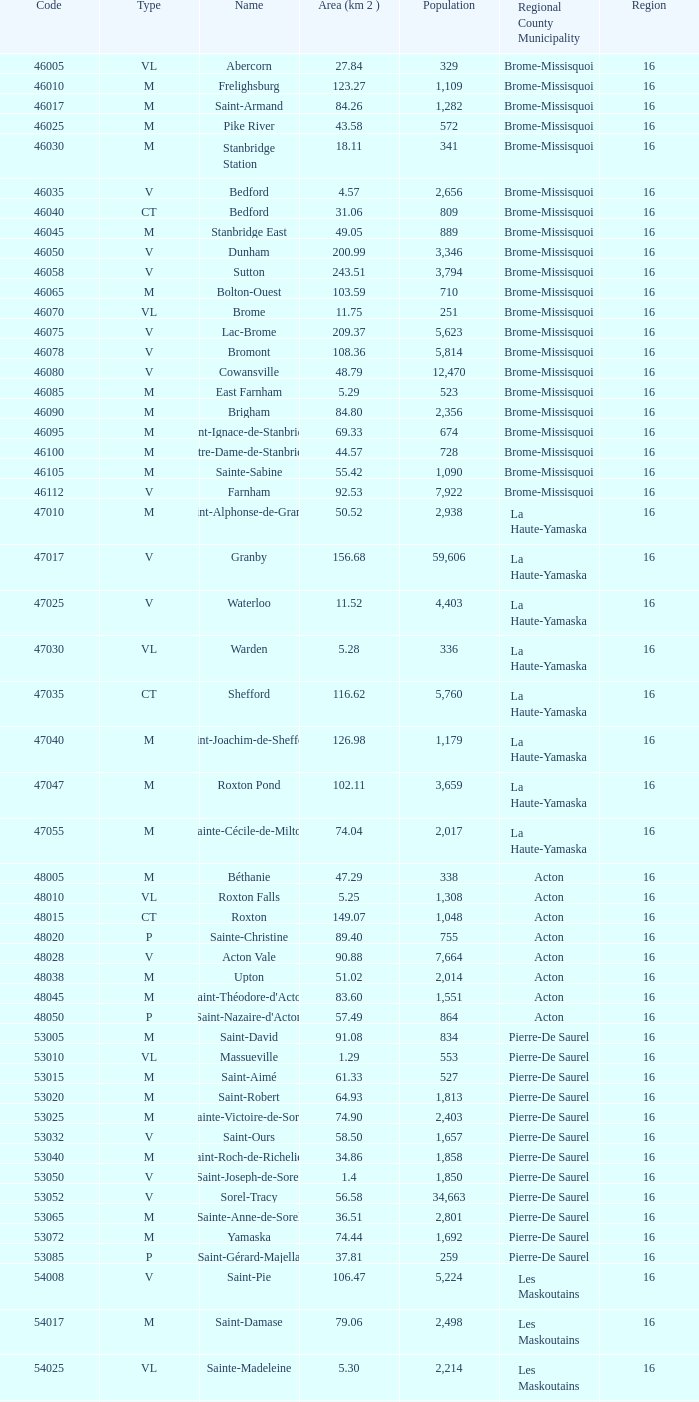Write the full table. {'header': ['Code', 'Type', 'Name', 'Area (km 2 )', 'Population', 'Regional County Municipality', 'Region'], 'rows': [['46005', 'VL', 'Abercorn', '27.84', '329', 'Brome-Missisquoi', '16'], ['46010', 'M', 'Frelighsburg', '123.27', '1,109', 'Brome-Missisquoi', '16'], ['46017', 'M', 'Saint-Armand', '84.26', '1,282', 'Brome-Missisquoi', '16'], ['46025', 'M', 'Pike River', '43.58', '572', 'Brome-Missisquoi', '16'], ['46030', 'M', 'Stanbridge Station', '18.11', '341', 'Brome-Missisquoi', '16'], ['46035', 'V', 'Bedford', '4.57', '2,656', 'Brome-Missisquoi', '16'], ['46040', 'CT', 'Bedford', '31.06', '809', 'Brome-Missisquoi', '16'], ['46045', 'M', 'Stanbridge East', '49.05', '889', 'Brome-Missisquoi', '16'], ['46050', 'V', 'Dunham', '200.99', '3,346', 'Brome-Missisquoi', '16'], ['46058', 'V', 'Sutton', '243.51', '3,794', 'Brome-Missisquoi', '16'], ['46065', 'M', 'Bolton-Ouest', '103.59', '710', 'Brome-Missisquoi', '16'], ['46070', 'VL', 'Brome', '11.75', '251', 'Brome-Missisquoi', '16'], ['46075', 'V', 'Lac-Brome', '209.37', '5,623', 'Brome-Missisquoi', '16'], ['46078', 'V', 'Bromont', '108.36', '5,814', 'Brome-Missisquoi', '16'], ['46080', 'V', 'Cowansville', '48.79', '12,470', 'Brome-Missisquoi', '16'], ['46085', 'M', 'East Farnham', '5.29', '523', 'Brome-Missisquoi', '16'], ['46090', 'M', 'Brigham', '84.80', '2,356', 'Brome-Missisquoi', '16'], ['46095', 'M', 'Saint-Ignace-de-Stanbridge', '69.33', '674', 'Brome-Missisquoi', '16'], ['46100', 'M', 'Notre-Dame-de-Stanbridge', '44.57', '728', 'Brome-Missisquoi', '16'], ['46105', 'M', 'Sainte-Sabine', '55.42', '1,090', 'Brome-Missisquoi', '16'], ['46112', 'V', 'Farnham', '92.53', '7,922', 'Brome-Missisquoi', '16'], ['47010', 'M', 'Saint-Alphonse-de-Granby', '50.52', '2,938', 'La Haute-Yamaska', '16'], ['47017', 'V', 'Granby', '156.68', '59,606', 'La Haute-Yamaska', '16'], ['47025', 'V', 'Waterloo', '11.52', '4,403', 'La Haute-Yamaska', '16'], ['47030', 'VL', 'Warden', '5.28', '336', 'La Haute-Yamaska', '16'], ['47035', 'CT', 'Shefford', '116.62', '5,760', 'La Haute-Yamaska', '16'], ['47040', 'M', 'Saint-Joachim-de-Shefford', '126.98', '1,179', 'La Haute-Yamaska', '16'], ['47047', 'M', 'Roxton Pond', '102.11', '3,659', 'La Haute-Yamaska', '16'], ['47055', 'M', 'Sainte-Cécile-de-Milton', '74.04', '2,017', 'La Haute-Yamaska', '16'], ['48005', 'M', 'Béthanie', '47.29', '338', 'Acton', '16'], ['48010', 'VL', 'Roxton Falls', '5.25', '1,308', 'Acton', '16'], ['48015', 'CT', 'Roxton', '149.07', '1,048', 'Acton', '16'], ['48020', 'P', 'Sainte-Christine', '89.40', '755', 'Acton', '16'], ['48028', 'V', 'Acton Vale', '90.88', '7,664', 'Acton', '16'], ['48038', 'M', 'Upton', '51.02', '2,014', 'Acton', '16'], ['48045', 'M', "Saint-Théodore-d'Acton", '83.60', '1,551', 'Acton', '16'], ['48050', 'P', "Saint-Nazaire-d'Acton", '57.49', '864', 'Acton', '16'], ['53005', 'M', 'Saint-David', '91.08', '834', 'Pierre-De Saurel', '16'], ['53010', 'VL', 'Massueville', '1.29', '553', 'Pierre-De Saurel', '16'], ['53015', 'M', 'Saint-Aimé', '61.33', '527', 'Pierre-De Saurel', '16'], ['53020', 'M', 'Saint-Robert', '64.93', '1,813', 'Pierre-De Saurel', '16'], ['53025', 'M', 'Sainte-Victoire-de-Sorel', '74.90', '2,403', 'Pierre-De Saurel', '16'], ['53032', 'V', 'Saint-Ours', '58.50', '1,657', 'Pierre-De Saurel', '16'], ['53040', 'M', 'Saint-Roch-de-Richelieu', '34.86', '1,858', 'Pierre-De Saurel', '16'], ['53050', 'V', 'Saint-Joseph-de-Sorel', '1.4', '1,850', 'Pierre-De Saurel', '16'], ['53052', 'V', 'Sorel-Tracy', '56.58', '34,663', 'Pierre-De Saurel', '16'], ['53065', 'M', 'Sainte-Anne-de-Sorel', '36.51', '2,801', 'Pierre-De Saurel', '16'], ['53072', 'M', 'Yamaska', '74.44', '1,692', 'Pierre-De Saurel', '16'], ['53085', 'P', 'Saint-Gérard-Majella', '37.81', '259', 'Pierre-De Saurel', '16'], ['54008', 'V', 'Saint-Pie', '106.47', '5,224', 'Les Maskoutains', '16'], ['54017', 'M', 'Saint-Damase', '79.06', '2,498', 'Les Maskoutains', '16'], ['54025', 'VL', 'Sainte-Madeleine', '5.30', '2,214', 'Les Maskoutains', '16'], ['54030', 'P', 'Sainte-Marie-Madeleine', '49.53', '2,713', 'Les Maskoutains', '16'], ['54035', 'M', 'La Présentation', '104.71', '2,078', 'Les Maskoutains', '16'], ['54048', 'V', 'Saint-Hyacinthe', '189.11', '51,984', 'Les Maskoutains', '16'], ['54060', 'M', 'Saint-Dominique', '70.16', '2,308', 'Les Maskoutains', '16'], ['54065', 'M', 'Saint-Valérien-de-Milton', '106.44', '1,785', 'Les Maskoutains', '16'], ['54072', 'M', 'Saint-Liboire', '72.90', '2,846', 'Les Maskoutains', '16'], ['54090', 'M', 'Saint-Simon', '68.66', '1,136', 'Les Maskoutains', '16'], ['54095', 'M', 'Sainte-Hélène-de-Bagot', '73.53', '1,541', 'Les Maskoutains', '16'], ['54100', 'M', 'Saint-Hugues', '89.30', '1,420', 'Les Maskoutains', '16'], ['54105', 'M', 'Saint-Barnabé-Sud', '57.08', '881', 'Les Maskoutains', '16'], ['54110', 'M', 'Saint-Jude', '77.36', '1,111', 'Les Maskoutains', '16'], ['54115', 'M', 'Saint-Bernard-de-Michaudville', '64.80', '581', 'Les Maskoutains', '16'], ['54120', 'M', 'Saint-Louis', '45.92', '752', 'Les Maskoutains', '16'], ['54125', 'M', 'Saint-Marcel-de-Richelieu', '50.21', '613', 'Les Maskoutains', '16'], ['55008', 'M', 'Ange-Gardien', '89.07', '1,994', 'Rouville', '16'], ['55015', 'M', "Saint-Paul-d'Abbotsford", '79.59', '2,910', 'Rouville', '16'], ['55023', 'V', 'Saint-Césaire', '84.14', '5,039', 'Rouville', '16'], ['55030', 'M', 'Sainte-Angèle-de-Monnoir', '45.49', '1,474', 'Rouville', '16'], ['55037', 'M', 'Rougemont', '44.48', '2,631', 'Rouville', '16'], ['55048', 'V', 'Marieville', '64.25', '7,377', 'Rouville', '16'], ['55057', 'V', 'Richelieu', '29.75', '5,658', 'Rouville', '16'], ['55065', 'M', 'Saint-Mathias-sur-Richelieu', '48.22', '4,453', 'Rouville', '16'], ['56005', 'M', 'Venise-en-Québec', '13.57', '1,414', 'Le Haut-Richelieu', '16'], ['56010', 'M', 'Saint-Georges-de-Clarenceville', '63.76', '1,170', 'Le Haut-Richelieu', '16'], ['56015', 'M', 'Noyan', '43.79', '1,192', 'Le Haut-Richelieu', '16'], ['56023', 'M', 'Lacolle', '49.17', '2,502', 'Le Haut-Richelieu', '16'], ['56030', 'M', 'Saint-Valentin', '40.09', '527', 'Le Haut-Richelieu', '16'], ['56035', 'M', "Saint-Paul-de-l'Île-aux-Noix", '29.47', '2,049', 'Le Haut-Richelieu', '16'], ['56042', 'M', 'Henryville', '64.87', '1,520', 'Le Haut-Richelieu', '16'], ['56050', 'M', 'Saint-Sébastien', '62.65', '759', 'Le Haut-Richelieu', '16'], ['56055', 'M', 'Saint-Alexandre', '76.55', '2,517', 'Le Haut-Richelieu', '16'], ['56060', 'P', 'Sainte-Anne-de-Sabrevois', '45.24', '1,964', 'Le Haut-Richelieu', '16'], ['56065', 'M', 'Saint-Blaise-sur-Richelieu', '68.42', '2,040', 'Le Haut-Richelieu', '16'], ['56083', 'V', 'Saint-Jean-sur-Richelieu', '225.61', '86,802', 'Le Haut-Richelieu', '16'], ['56097', 'M', 'Mont-Saint-Grégoire', '79.92', '3,077', 'Le Haut-Richelieu', '16'], ['56105', 'M', "Sainte-Brigide-d'Iberville", '68.89', '1,260', 'Le Haut-Richelieu', '16'], ['57005', 'V', 'Chambly', '25.01', '22,332', 'La Vallée-du-Richelieu', '16'], ['57010', 'V', 'Carignan', '62.39', '6,911', 'La Vallée-du-Richelieu', '16'], ['57020', 'V', 'Saint-Basile-le-Grand', '34.82', '15,100', 'La Vallée-du-Richelieu', '16'], ['57025', 'M', 'McMasterville', '3.00', '4,773', 'La Vallée-du-Richelieu', '16'], ['57030', 'V', 'Otterburn Park', '5.20', '8,696', 'La Vallée-du-Richelieu', '16'], ['57033', 'M', 'Saint-Jean-Baptiste', '75.98', '2,875', 'La Vallée-du-Richelieu', '16'], ['57035', 'V', 'Mont-Saint-Hilaire', '38.96', '15,820', 'La Vallée-du-Richelieu', '16'], ['57040', 'V', 'Beloeil', '24.00', '19,428', 'La Vallée-du-Richelieu', '16'], ['57045', 'M', 'Saint-Mathieu-de-Beloeil', '39.26', '2,381', 'La Vallée-du-Richelieu', '16'], ['57050', 'M', 'Saint-Marc-sur-Richelieu', '59.51', '1,992', 'La Vallée-du-Richelieu', '16'], ['57057', 'M', 'Saint-Charles-sur-Richelieu', '63.59', '1,808', 'La Vallée-du-Richelieu', '16'], ['57068', 'M', 'Saint-Denis-sur-Richelieu', '82.20', '2,272', 'La Vallée-du-Richelieu', '16'], ['57075', 'M', 'Saint-Antoine-sur-Richelieu', '65.26', '1,571', 'La Vallée-du-Richelieu', '16'], ['58007', 'V', 'Brossard', '44.77', '71,372', 'Not part of a RCM', '16'], ['58012', 'V', 'Saint-Lambert', '6.43', '21,772', 'Not part of a RCM', '16'], ['58033', 'V', 'Boucherville', '69.33', '38,526', 'Not part of a RCM', '16'], ['58037', 'V', 'Saint-Bruno-de-Montarville', '41.89', '24,571', 'Not part of a RCM', '16'], ['58227', 'V', 'Longueuil', '111.50', '231,969', 'Not part of a RCM', '16'], ['59010', 'V', 'Sainte-Julie', '47.78', '29,000', "Marguerite-D'Youville", '16'], ['59015', 'M', 'Saint-Amable', '38.04', '8,135', "Marguerite-D'Youville", '16'], ['59020', 'V', 'Varennes', '93.96', '20,608', "Marguerite-D'Youville", '16'], ['59025', 'M', 'Verchères', '72.77', '5,103', "Marguerite-D'Youville", '16'], ['59030', 'P', 'Calixa-Lavallée', '32.42', '517', "Marguerite-D'Youville", '16'], ['59035', 'V', 'Contrecœur', '61.56', '5,603', "Marguerite-D'Youville", '16'], ['67005', 'M', 'Saint-Mathieu', '32.27', '2,032', 'Roussillon', '16'], ['67010', 'M', 'Saint-Philippe', '61.66', '4,763', 'Roussillon', '16'], ['67015', 'V', 'La Prairie', '43.53', '21,609', 'Roussillon', '16'], ['67020', 'V', 'Candiac', '16.40', '14,866', 'Roussillon', '16'], ['67025', 'V', 'Delson', '7.76', '7,382', 'Roussillon', '16'], ['67030', 'V', 'Sainte-Catherine', '9.06', '16,770', 'Roussillon', '16'], ['67035', 'V', 'Saint-Constant', '56.58', '24,679', 'Roussillon', '16'], ['67040', 'P', 'Saint-Isidore', '52.00', '2,476', 'Roussillon', '16'], ['67045', 'V', 'Mercier', '45.89', '10,231', 'Roussillon', '16'], ['67050', 'V', 'Châteauguay', '35.37', '43,178', 'Roussillon', '16'], ['67055', 'V', 'Léry', '10.98', '2,368', 'Roussillon', '16'], ['68005', 'P', 'Saint-Bernard-de-Lacolle', '112.63', '1,601', 'Les Jardins-de-Napierville', '16'], ['68010', 'VL', 'Hemmingford', '0.85', '737', 'Les Jardins-de-Napierville', '16'], ['68015', 'CT', 'Hemmingford', '155.78', '1,735', 'Les Jardins-de-Napierville', '16'], ['68020', 'M', 'Sainte-Clotilde', '78.96', '1,593', 'Les Jardins-de-Napierville', '16'], ['68025', 'M', 'Saint-Patrice-de-Sherrington', '91.47', '1,946', 'Les Jardins-de-Napierville', '16'], ['68030', 'M', 'Napierville', '4.53', '3,310', 'Les Jardins-de-Napierville', '16'], ['68035', 'M', 'Saint-Cyprien-de-Napierville', '97.62', '1,414', 'Les Jardins-de-Napierville', '16'], ['68040', 'M', 'Saint-Jacques-le-Mineur', '65.19', '1,670', 'Les Jardins-de-Napierville', '16'], ['68045', 'M', 'Saint-Édouard', '52.91', '1,226', 'Les Jardins-de-Napierville', '16'], ['68050', 'M', 'Saint-Michel', '57.36', '2,681', 'Les Jardins-de-Napierville', '16'], ['68055', 'V', 'Saint-Rémi', '79.66', '6,089', 'Les Jardins-de-Napierville', '16'], ['69005', 'CT', 'Havelock', '87.98', '853', 'Le Haut-Saint-Laurent', '16'], ['69010', 'M', 'Franklin', '112.19', '1,601', 'Le Haut-Saint-Laurent', '16'], ['69017', 'M', 'Saint-Chrysostome', '99.54', '2,689', 'Le Haut-Saint-Laurent', '16'], ['69025', 'M', 'Howick', '0.89', '589', 'Le Haut-Saint-Laurent', '16'], ['69030', 'P', 'Très-Saint-Sacrement', '97.30', '1,250', 'Le Haut-Saint-Laurent', '16'], ['69037', 'M', 'Ormstown', '142.39', '3,742', 'Le Haut-Saint-Laurent', '16'], ['69045', 'M', 'Hinchinbrooke', '148.95', '2,425', 'Le Haut-Saint-Laurent', '16'], ['69050', 'M', 'Elgin', '69.38', '463', 'Le Haut-Saint-Laurent', '16'], ['69055', 'V', 'Huntingdon', '2.58', '2,695', 'Le Haut-Saint-Laurent', '16'], ['69060', 'CT', 'Godmanchester', '138.77', '1,512', 'Le Haut-Saint-Laurent', '16'], ['69065', 'M', 'Sainte-Barbe', '39.78', '1,407', 'Le Haut-Saint-Laurent', '16'], ['69070', 'M', 'Saint-Anicet', '136.25', '2,736', 'Le Haut-Saint-Laurent', '16'], ['69075', 'CT', 'Dundee', '94.20', '406', 'Le Haut-Saint-Laurent', '16'], ['70005', 'M', 'Saint-Urbain-Premier', '52.24', '1,181', 'Beauharnois-Salaberry', '16'], ['70012', 'M', 'Sainte-Martine', '59.79', '4,037', 'Beauharnois-Salaberry', '16'], ['70022', 'V', 'Beauharnois', '73.05', '12,041', 'Beauharnois-Salaberry', '16'], ['70030', 'M', 'Saint-Étienne-de-Beauharnois', '41.62', '738', 'Beauharnois-Salaberry', '16'], ['70035', 'P', 'Saint-Louis-de-Gonzague', '78.52', '1,402', 'Beauharnois-Salaberry', '16'], ['70040', 'M', 'Saint-Stanislas-de-Kostka', '62.16', '1,653', 'Beauharnois-Salaberry', '16'], ['70052', 'V', 'Salaberry-de-Valleyfield', '100.96', '40,056', 'Beauharnois-Salaberry', '16'], ['71005', 'M', 'Rivière-Beaudette', '19.62', '1,701', 'Vaudreuil-Soulanges', '16'], ['71015', 'M', 'Saint-Télesphore', '59.62', '777', 'Vaudreuil-Soulanges', '16'], ['71020', 'M', 'Saint-Polycarpe', '70.80', '1,737', 'Vaudreuil-Soulanges', '16'], ['71025', 'M', 'Saint-Zotique', '24.24', '4,947', 'Vaudreuil-Soulanges', '16'], ['71033', 'M', 'Les Coteaux', '12.11', '3,684', 'Vaudreuil-Soulanges', '16'], ['71040', 'V', 'Coteau-du-Lac', '46.57', '6,458', 'Vaudreuil-Soulanges', '16'], ['71045', 'M', 'Saint-Clet', '38.61', '1,663', 'Vaudreuil-Soulanges', '16'], ['71050', 'M', 'Les Cèdres', '78.31', '5,842', 'Vaudreuil-Soulanges', '16'], ['71055', 'VL', 'Pointe-des-Cascades', '2.66', '1,014', 'Vaudreuil-Soulanges', '16'], ['71060', 'V', "L'Île-Perrot", '4.86', '10,131', 'Vaudreuil-Soulanges', '16'], ['71065', 'V', "Notre-Dame-de-l'Île-Perrot", '28.14', '9,783', 'Vaudreuil-Soulanges', '16'], ['71070', 'V', 'Pincourt', '8.36', '10,960', 'Vaudreuil-Soulanges', '16'], ['71075', 'M', 'Terrasse-Vaudreuil', '1.08', '2,086', 'Vaudreuil-Soulanges', '16'], ['71083', 'V', 'Vaudreuil-Dorion', '73.18', '24,589', 'Vaudreuil-Soulanges', '16'], ['71090', 'VL', 'Vaudreuil-sur-le-Lac', '1.73', '1,058', 'Vaudreuil-Soulanges', '16'], ['71095', 'V', "L'Île-Cadieux", '0.62', '141', 'Vaudreuil-Soulanges', '16'], ['71100', 'V', 'Hudson', '21.62', '5,193', 'Vaudreuil-Soulanges', '16'], ['71105', 'V', 'Saint-Lazare', '67.59', '15,954', 'Vaudreuil-Soulanges', '16'], ['71110', 'M', 'Sainte-Marthe', '80.23', '1,142', 'Vaudreuil-Soulanges', '16'], ['71115', 'M', 'Sainte-Justine-de-Newton', '84.14', '968', 'Vaudreuil-Soulanges', '16'], ['71125', 'M', 'Très-Saint-Rédempteur', '25.40', '645', 'Vaudreuil-Soulanges', '16'], ['71133', 'M', 'Rigaud', '97.15', '6,724', 'Vaudreuil-Soulanges', '16'], ['71140', 'VL', 'Pointe-Fortune', '9.09', '512', 'Vaudreuil-Soulanges', '16']]} What code represents a le haut-saint-laurent municipality that encompasses 16 or more regions? None. 